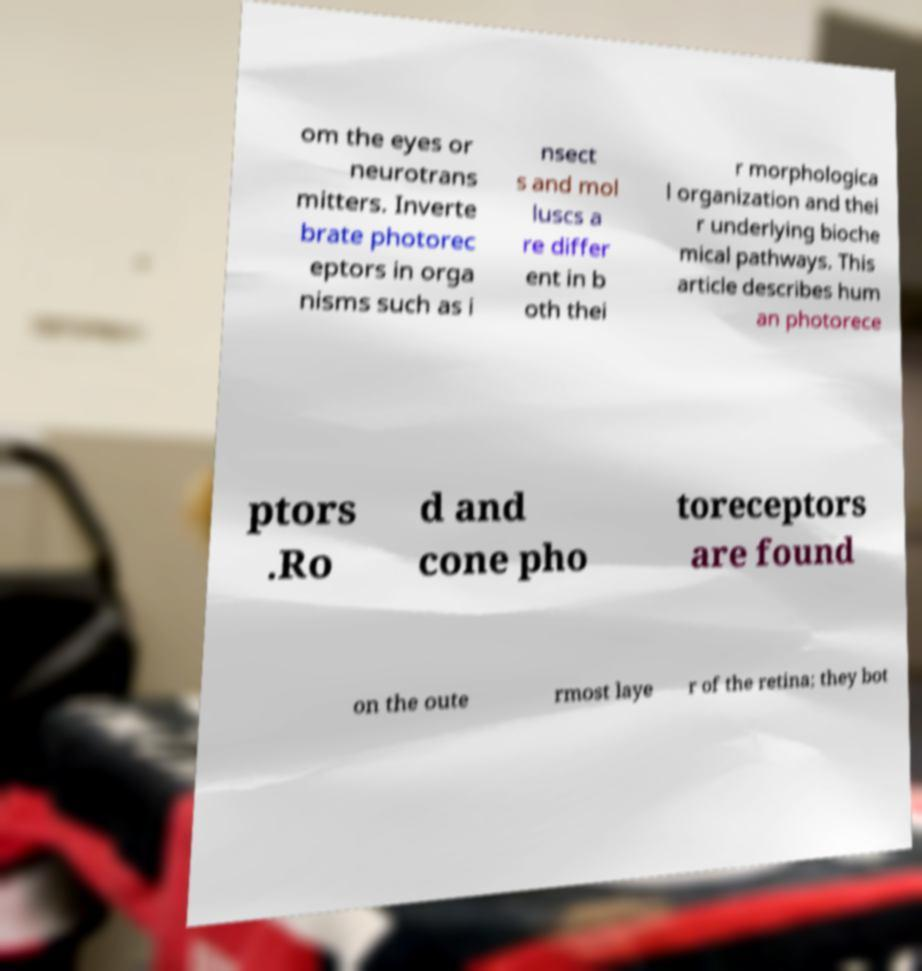Can you accurately transcribe the text from the provided image for me? om the eyes or neurotrans mitters. Inverte brate photorec eptors in orga nisms such as i nsect s and mol luscs a re differ ent in b oth thei r morphologica l organization and thei r underlying bioche mical pathways. This article describes hum an photorece ptors .Ro d and cone pho toreceptors are found on the oute rmost laye r of the retina; they bot 